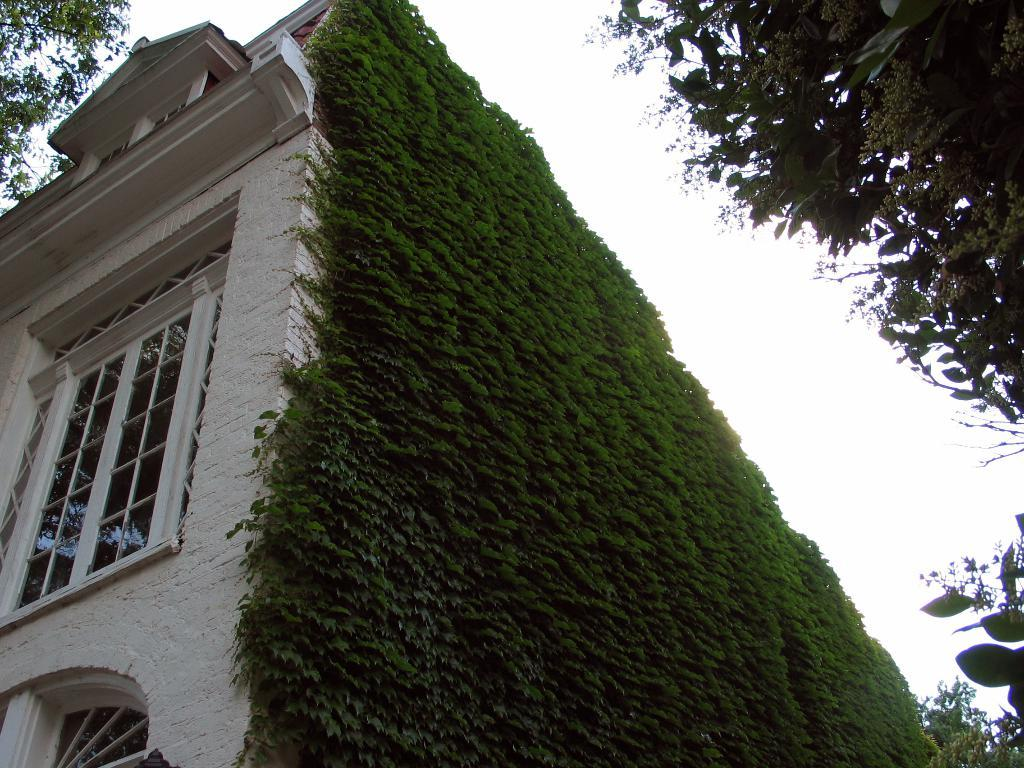What is the color and material of the building in the image? The building in the image is brown and made of a solid material, likely concrete or brick. What type of windows does the building have? The building has glass windows. What can be seen on the wall beside the building? There are green vertical garden plants on the wall beside the building. What is located on the right side of the image? There is a tree on the right side of the image. Can you tell me how many times your aunt has shaken the cheese in the image? There is no aunt or cheese present in the image, so this question cannot be answered. 